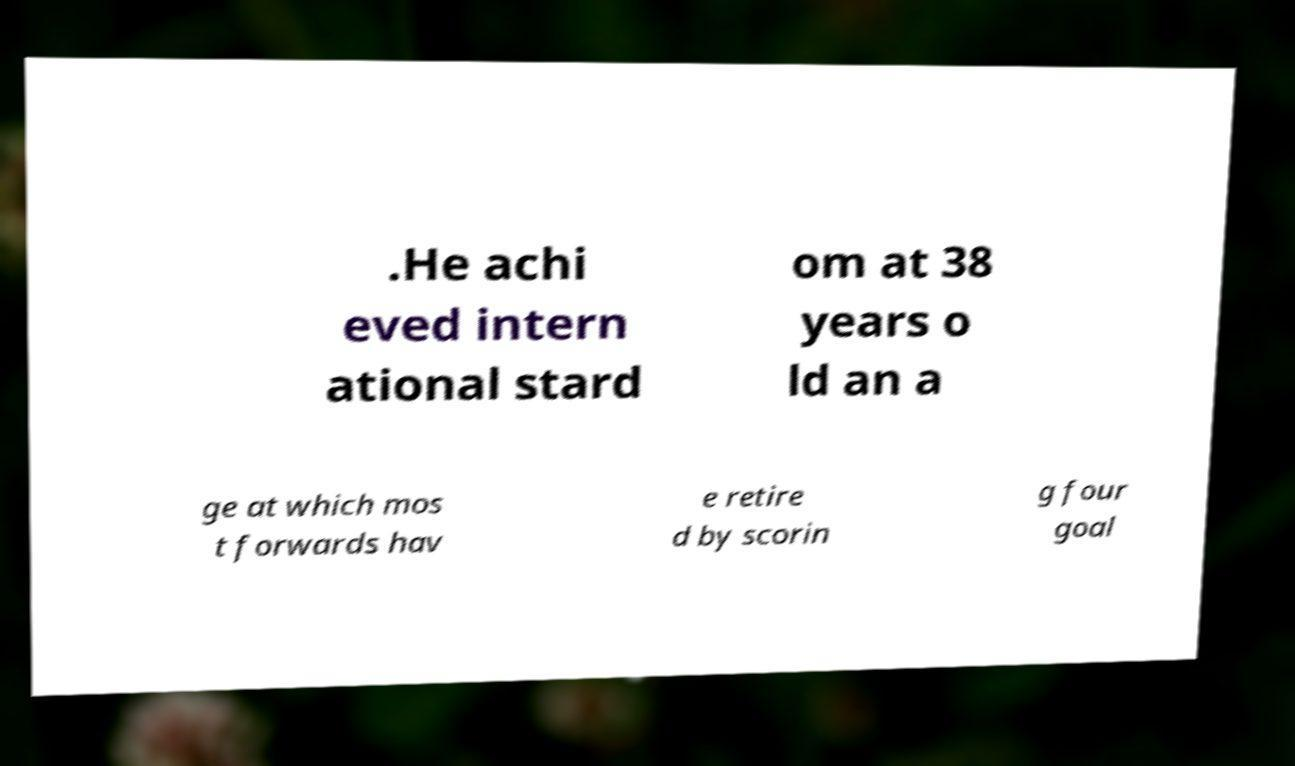Can you read and provide the text displayed in the image?This photo seems to have some interesting text. Can you extract and type it out for me? .He achi eved intern ational stard om at 38 years o ld an a ge at which mos t forwards hav e retire d by scorin g four goal 